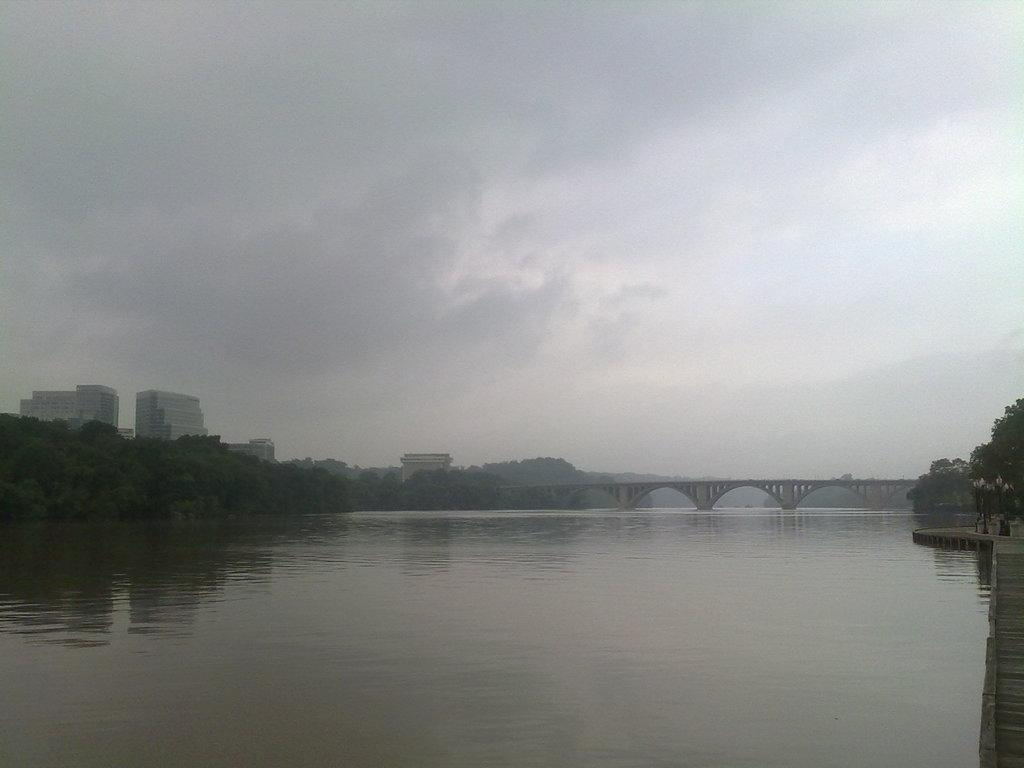What is the main feature of the image? There is water in the image. What structure can be seen crossing over the water? There is a bridge in the image. What type of vegetation is present in the image? There are trees in the image. What type of man-made structure is visible in the image? There is a building in the image. How would you describe the weather in the image? The sky is cloudy in the image. What type of line is being discussed by the committee in the image? There is no line or committee present in the image. What day is it in the image? The day cannot be determined from the image, as it does not provide any information about the date or time. 